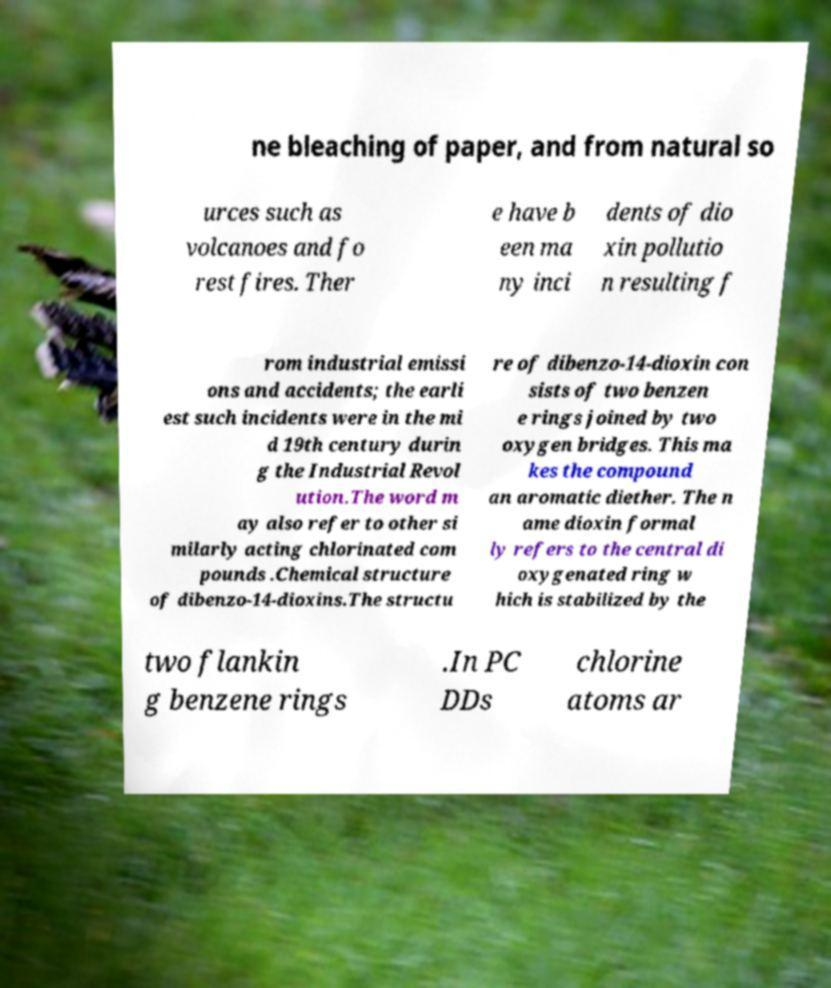What messages or text are displayed in this image? I need them in a readable, typed format. ne bleaching of paper, and from natural so urces such as volcanoes and fo rest fires. Ther e have b een ma ny inci dents of dio xin pollutio n resulting f rom industrial emissi ons and accidents; the earli est such incidents were in the mi d 19th century durin g the Industrial Revol ution.The word m ay also refer to other si milarly acting chlorinated com pounds .Chemical structure of dibenzo-14-dioxins.The structu re of dibenzo-14-dioxin con sists of two benzen e rings joined by two oxygen bridges. This ma kes the compound an aromatic diether. The n ame dioxin formal ly refers to the central di oxygenated ring w hich is stabilized by the two flankin g benzene rings .In PC DDs chlorine atoms ar 